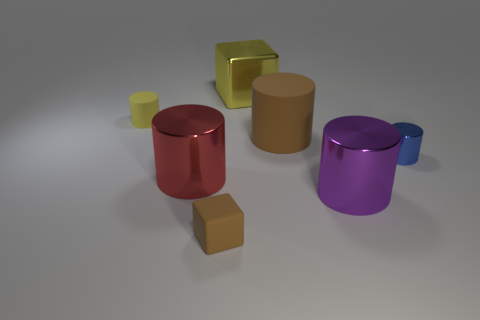Subtract all tiny blue cylinders. How many cylinders are left? 4 Subtract all yellow cubes. How many cubes are left? 1 Subtract all cylinders. How many objects are left? 2 Add 3 tiny blue things. How many objects exist? 10 Subtract 1 cubes. How many cubes are left? 1 Add 6 big red objects. How many big red objects are left? 7 Add 7 small brown rubber things. How many small brown rubber things exist? 8 Subtract 1 red cylinders. How many objects are left? 6 Subtract all yellow cubes. Subtract all brown cylinders. How many cubes are left? 1 Subtract all blue spheres. How many yellow cylinders are left? 1 